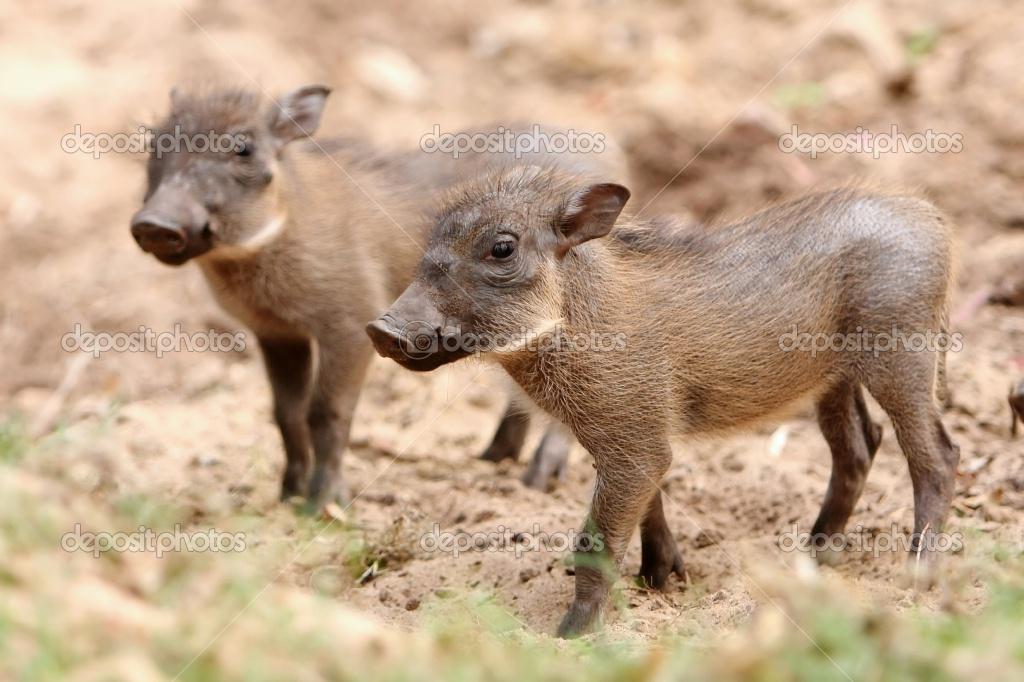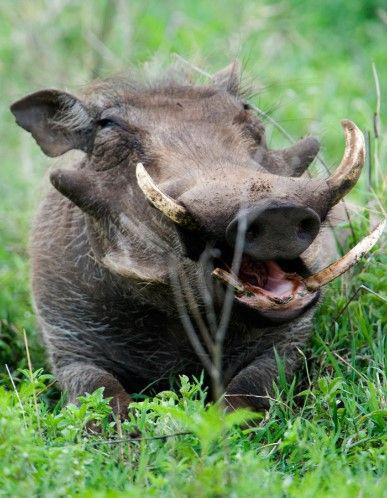The first image is the image on the left, the second image is the image on the right. Evaluate the accuracy of this statement regarding the images: "An image contains only young hogs, all without distinctive patterned fur.". Is it true? Answer yes or no. Yes. The first image is the image on the left, the second image is the image on the right. Examine the images to the left and right. Is the description "There are no more than 3 hogs in total." accurate? Answer yes or no. Yes. 